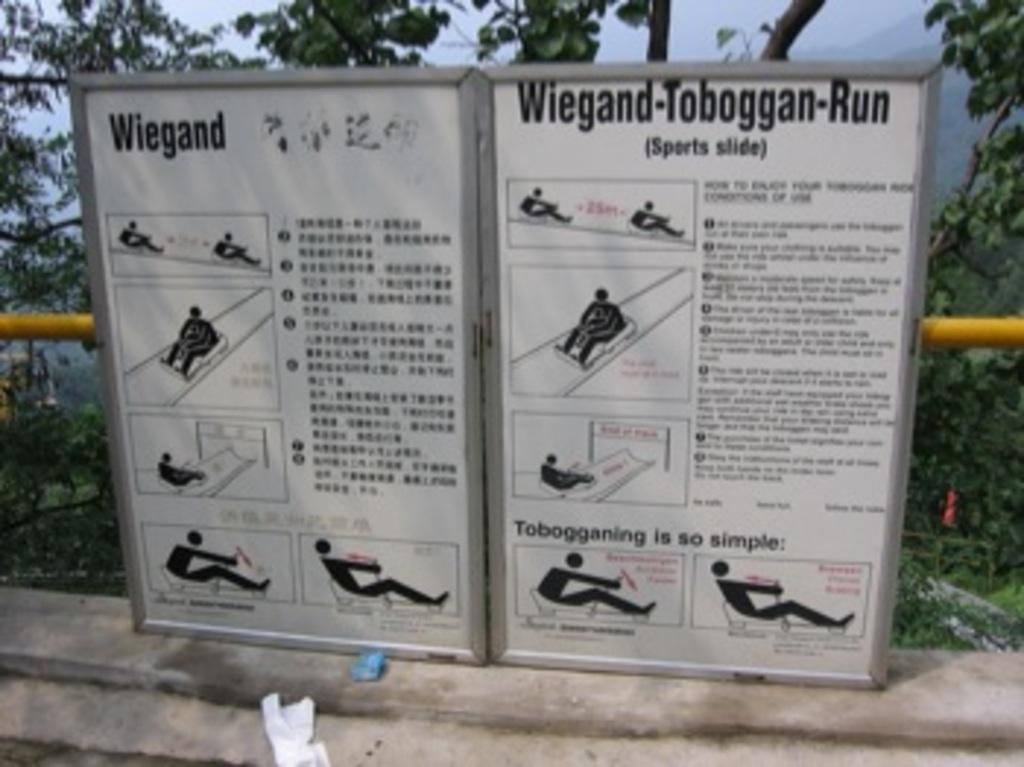What is the main object in the image? There is a sign board in the image. What can be found on the sign board? The sign board contains pictures and text. What else is present in the image? There is a railing and plants in the image. Can you tell me how many dogs are sitting on the railing in the image? There are no dogs present in the image; it only features a sign board, railing, and plants. What type of beam is supporting the sign board in the image? There is no beam visible in the image, as the focus is on the sign board, railing, and plants. 